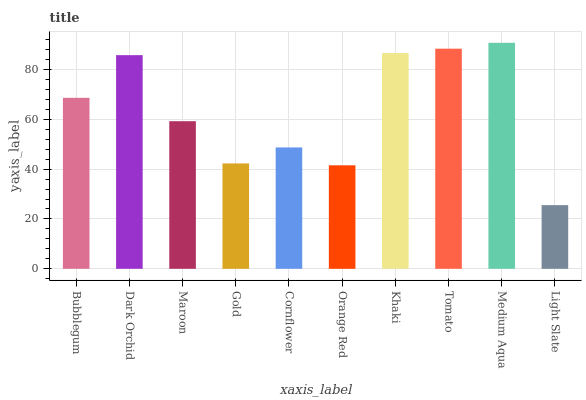Is Dark Orchid the minimum?
Answer yes or no. No. Is Dark Orchid the maximum?
Answer yes or no. No. Is Dark Orchid greater than Bubblegum?
Answer yes or no. Yes. Is Bubblegum less than Dark Orchid?
Answer yes or no. Yes. Is Bubblegum greater than Dark Orchid?
Answer yes or no. No. Is Dark Orchid less than Bubblegum?
Answer yes or no. No. Is Bubblegum the high median?
Answer yes or no. Yes. Is Maroon the low median?
Answer yes or no. Yes. Is Maroon the high median?
Answer yes or no. No. Is Light Slate the low median?
Answer yes or no. No. 